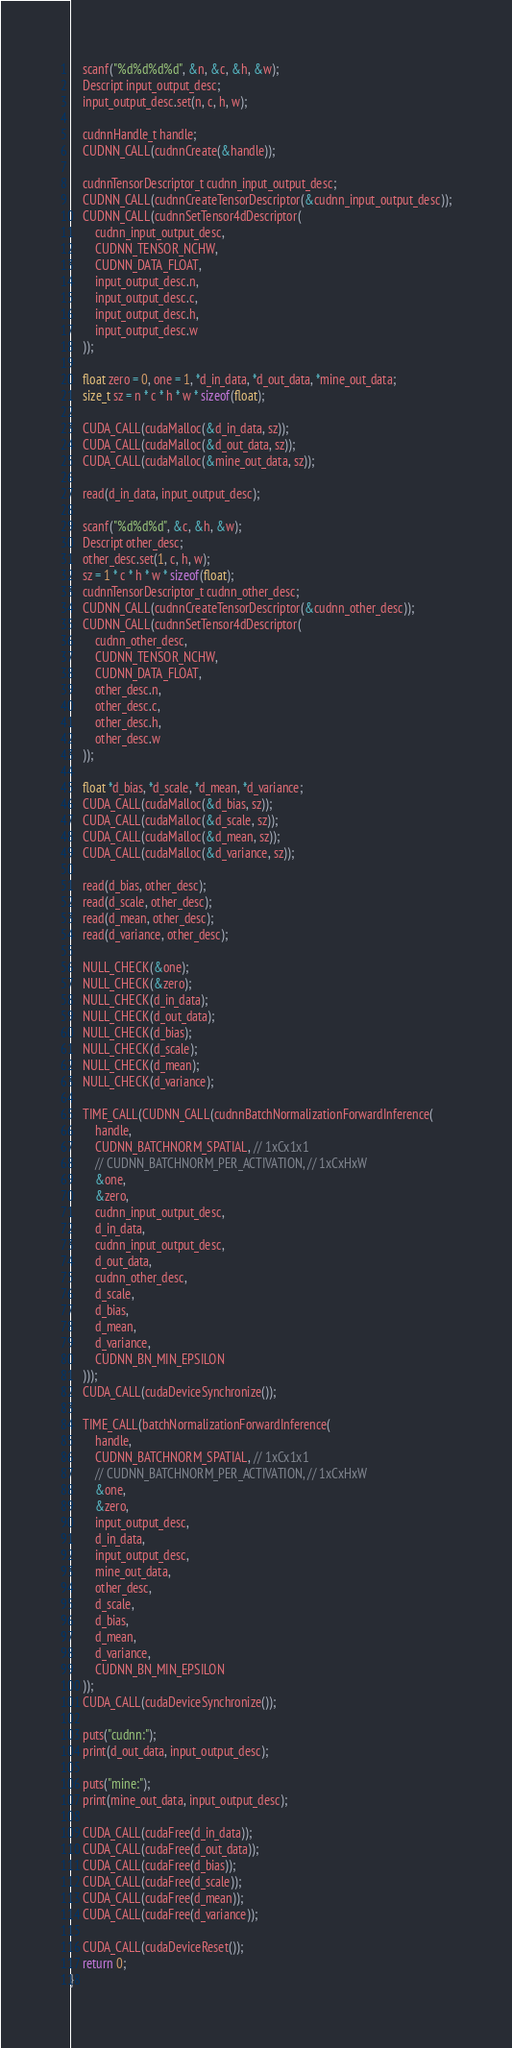<code> <loc_0><loc_0><loc_500><loc_500><_Cuda_>	scanf("%d%d%d%d", &n, &c, &h, &w);
	Descript input_output_desc;
	input_output_desc.set(n, c, h, w);

	cudnnHandle_t handle;
	CUDNN_CALL(cudnnCreate(&handle));

	cudnnTensorDescriptor_t cudnn_input_output_desc;
	CUDNN_CALL(cudnnCreateTensorDescriptor(&cudnn_input_output_desc));
	CUDNN_CALL(cudnnSetTensor4dDescriptor(
		cudnn_input_output_desc,
		CUDNN_TENSOR_NCHW,
		CUDNN_DATA_FLOAT,
		input_output_desc.n,
		input_output_desc.c,
		input_output_desc.h,
		input_output_desc.w
	));

	float zero = 0, one = 1, *d_in_data, *d_out_data, *mine_out_data;
	size_t sz = n * c * h * w * sizeof(float);

	CUDA_CALL(cudaMalloc(&d_in_data, sz));
	CUDA_CALL(cudaMalloc(&d_out_data, sz));
	CUDA_CALL(cudaMalloc(&mine_out_data, sz));

	read(d_in_data, input_output_desc);

	scanf("%d%d%d", &c, &h, &w);
	Descript other_desc;
	other_desc.set(1, c, h, w);
	sz = 1 * c * h * w * sizeof(float);
	cudnnTensorDescriptor_t cudnn_other_desc;
	CUDNN_CALL(cudnnCreateTensorDescriptor(&cudnn_other_desc));
	CUDNN_CALL(cudnnSetTensor4dDescriptor(
		cudnn_other_desc,
		CUDNN_TENSOR_NCHW,
		CUDNN_DATA_FLOAT,
		other_desc.n,
		other_desc.c,
		other_desc.h,
		other_desc.w
	));

	float *d_bias, *d_scale, *d_mean, *d_variance;
	CUDA_CALL(cudaMalloc(&d_bias, sz));
	CUDA_CALL(cudaMalloc(&d_scale, sz));
	CUDA_CALL(cudaMalloc(&d_mean, sz));
	CUDA_CALL(cudaMalloc(&d_variance, sz));

	read(d_bias, other_desc);
	read(d_scale, other_desc);
	read(d_mean, other_desc);
	read(d_variance, other_desc);

	NULL_CHECK(&one);
	NULL_CHECK(&zero);
	NULL_CHECK(d_in_data);
	NULL_CHECK(d_out_data);
	NULL_CHECK(d_bias);
	NULL_CHECK(d_scale);
	NULL_CHECK(d_mean);
	NULL_CHECK(d_variance);

	TIME_CALL(CUDNN_CALL(cudnnBatchNormalizationForwardInference(
		handle,
		CUDNN_BATCHNORM_SPATIAL, // 1xCx1x1
		// CUDNN_BATCHNORM_PER_ACTIVATION, // 1xCxHxW
		&one,
		&zero,
		cudnn_input_output_desc,
		d_in_data,
		cudnn_input_output_desc,
		d_out_data,
		cudnn_other_desc,
		d_scale,
		d_bias,
		d_mean,
		d_variance,
		CUDNN_BN_MIN_EPSILON
	)));
	CUDA_CALL(cudaDeviceSynchronize());

	TIME_CALL(batchNormalizationForwardInference(
		handle,
		CUDNN_BATCHNORM_SPATIAL, // 1xCx1x1
		// CUDNN_BATCHNORM_PER_ACTIVATION, // 1xCxHxW
		&one,
		&zero,
		input_output_desc,
		d_in_data,
		input_output_desc,
		mine_out_data,
		other_desc,
		d_scale,
		d_bias,
		d_mean,
		d_variance,
		CUDNN_BN_MIN_EPSILON
	));
	CUDA_CALL(cudaDeviceSynchronize());

	puts("cudnn:");
	print(d_out_data, input_output_desc);

	puts("mine:");
	print(mine_out_data, input_output_desc);

	CUDA_CALL(cudaFree(d_in_data));
	CUDA_CALL(cudaFree(d_out_data));
	CUDA_CALL(cudaFree(d_bias));
	CUDA_CALL(cudaFree(d_scale));
	CUDA_CALL(cudaFree(d_mean));
	CUDA_CALL(cudaFree(d_variance));

	CUDA_CALL(cudaDeviceReset());
	return 0;
}


</code> 